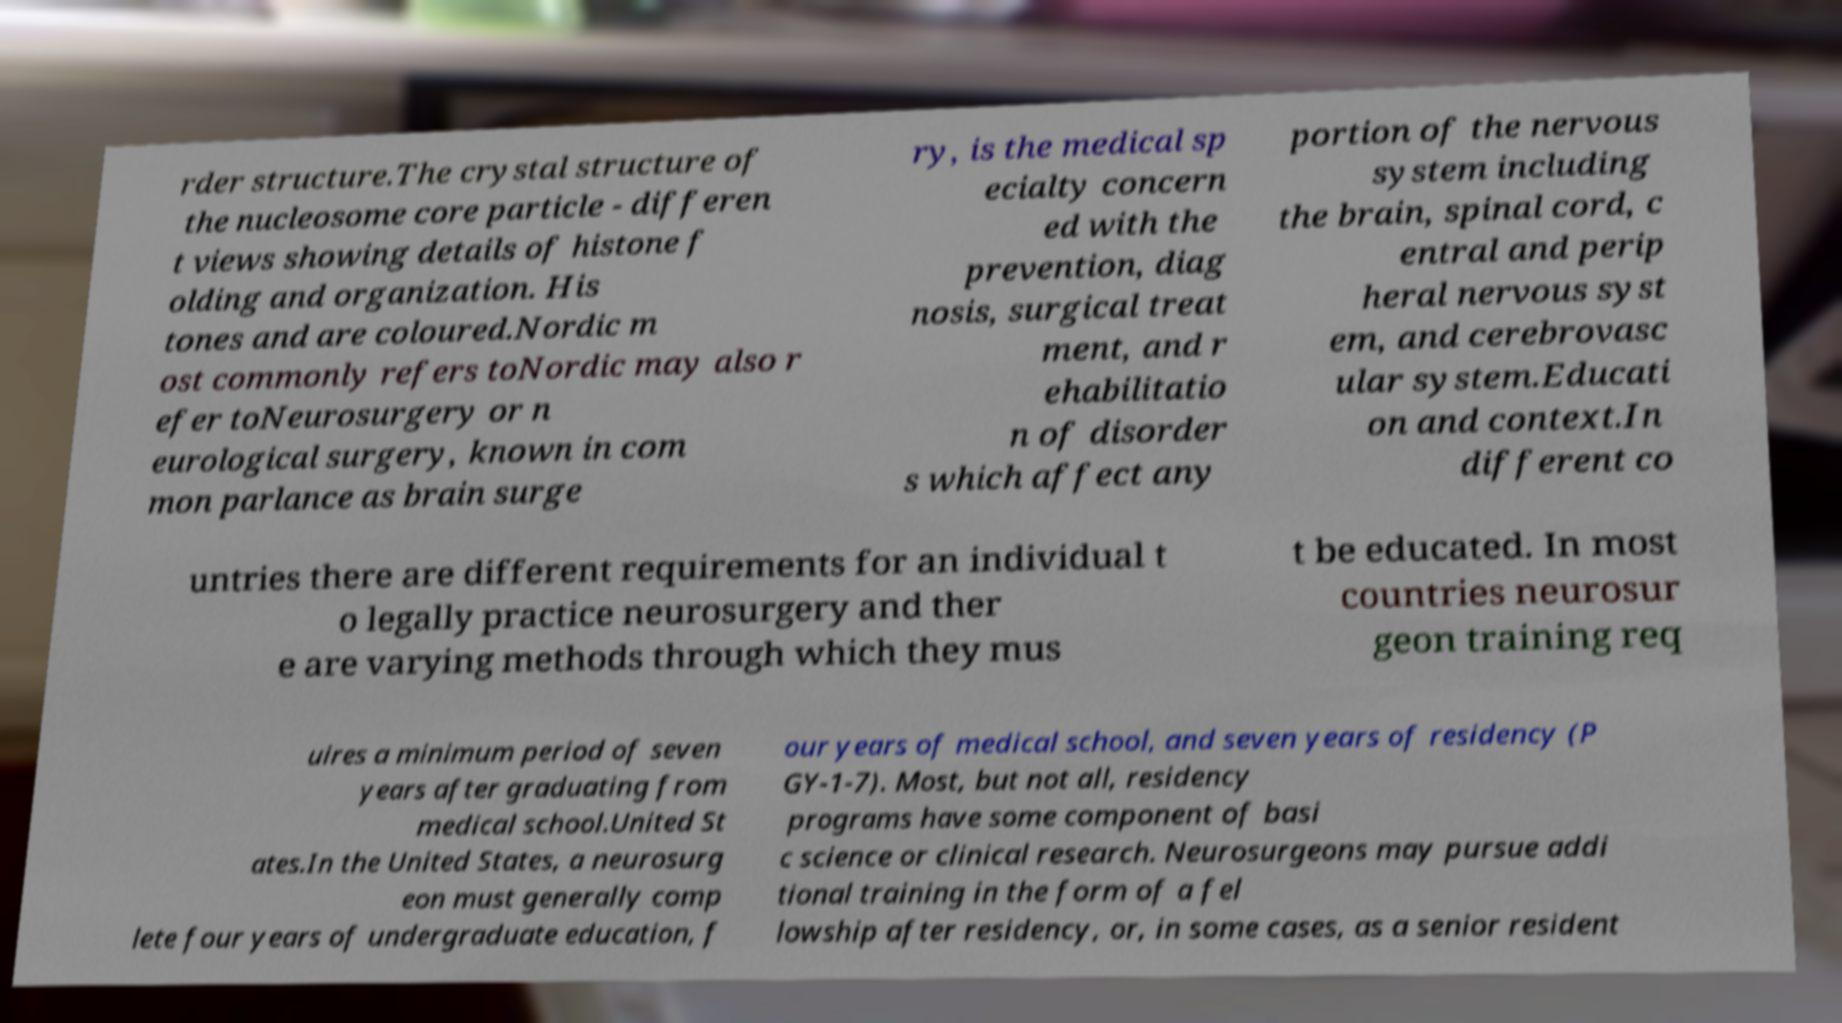What messages or text are displayed in this image? I need them in a readable, typed format. rder structure.The crystal structure of the nucleosome core particle - differen t views showing details of histone f olding and organization. His tones and are coloured.Nordic m ost commonly refers toNordic may also r efer toNeurosurgery or n eurological surgery, known in com mon parlance as brain surge ry, is the medical sp ecialty concern ed with the prevention, diag nosis, surgical treat ment, and r ehabilitatio n of disorder s which affect any portion of the nervous system including the brain, spinal cord, c entral and perip heral nervous syst em, and cerebrovasc ular system.Educati on and context.In different co untries there are different requirements for an individual t o legally practice neurosurgery and ther e are varying methods through which they mus t be educated. In most countries neurosur geon training req uires a minimum period of seven years after graduating from medical school.United St ates.In the United States, a neurosurg eon must generally comp lete four years of undergraduate education, f our years of medical school, and seven years of residency (P GY-1-7). Most, but not all, residency programs have some component of basi c science or clinical research. Neurosurgeons may pursue addi tional training in the form of a fel lowship after residency, or, in some cases, as a senior resident 